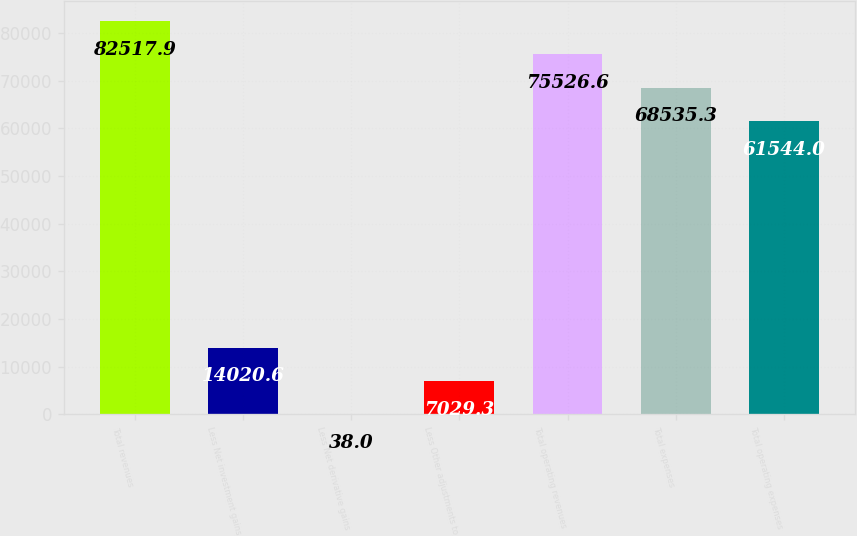<chart> <loc_0><loc_0><loc_500><loc_500><bar_chart><fcel>Total revenues<fcel>Less Net investment gains<fcel>Less Net derivative gains<fcel>Less Other adjustments to<fcel>Total operating revenues<fcel>Total expenses<fcel>Total operating expenses<nl><fcel>82517.9<fcel>14020.6<fcel>38<fcel>7029.3<fcel>75526.6<fcel>68535.3<fcel>61544<nl></chart> 